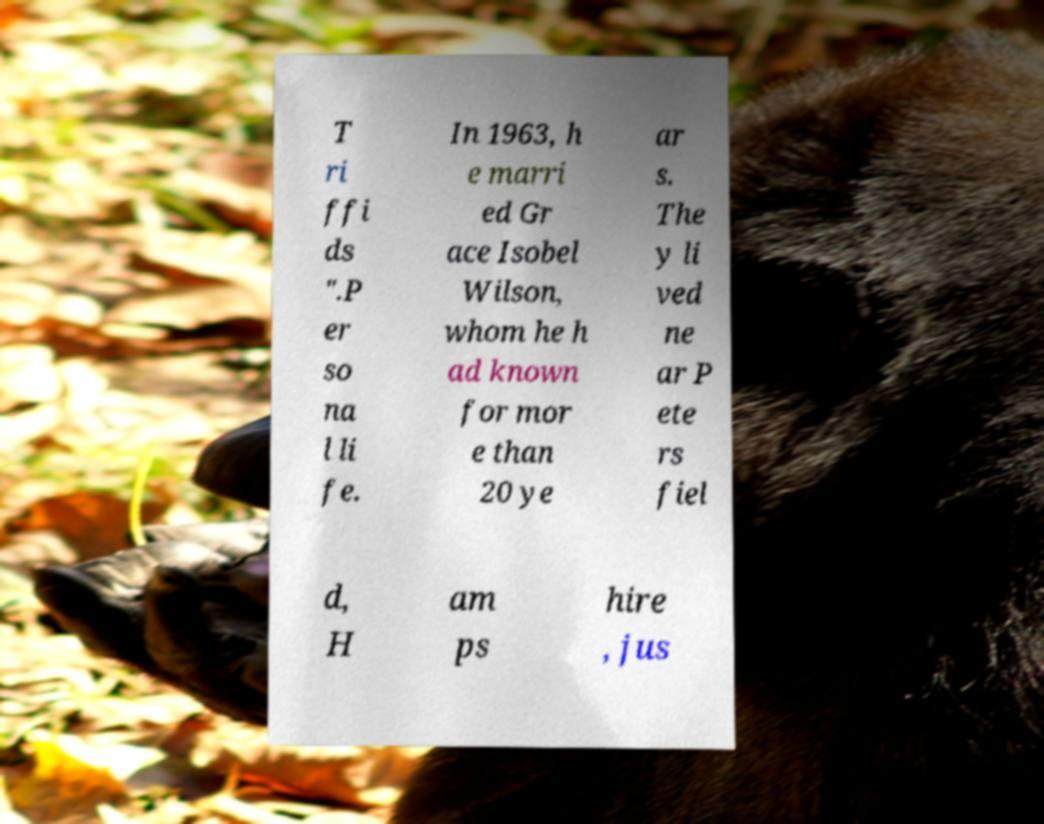Please identify and transcribe the text found in this image. T ri ffi ds ".P er so na l li fe. In 1963, h e marri ed Gr ace Isobel Wilson, whom he h ad known for mor e than 20 ye ar s. The y li ved ne ar P ete rs fiel d, H am ps hire , jus 